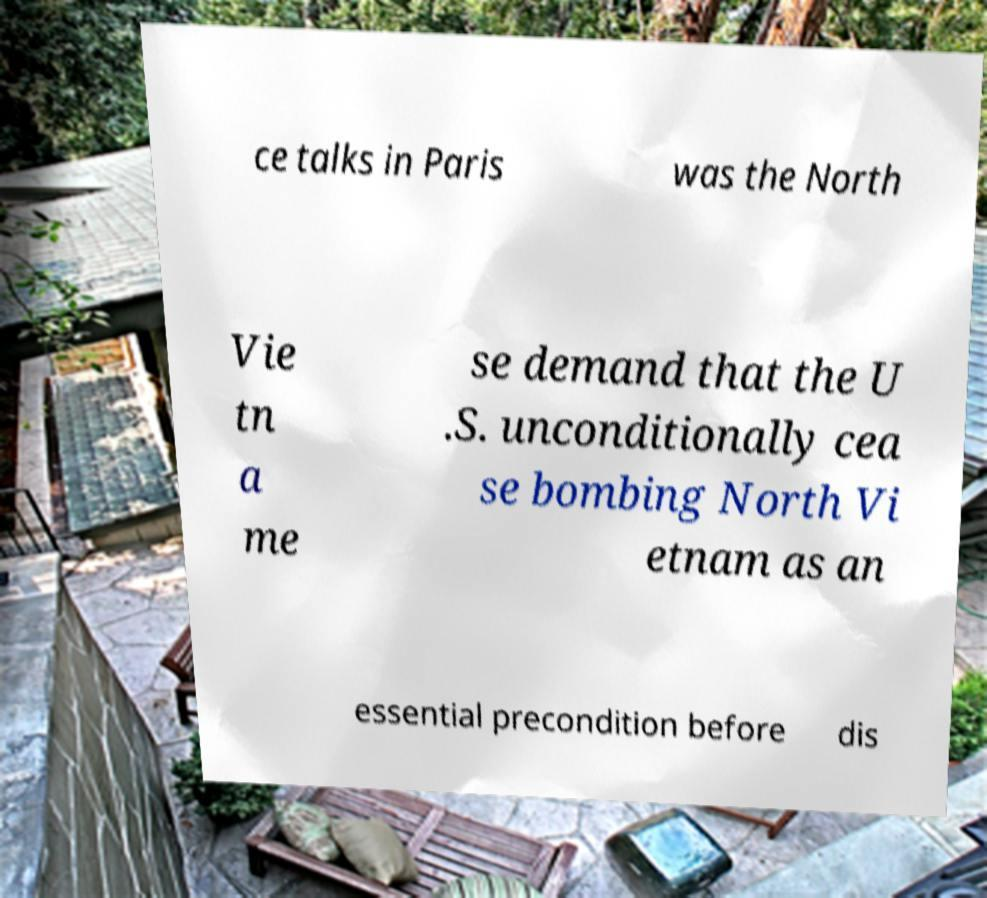I need the written content from this picture converted into text. Can you do that? ce talks in Paris was the North Vie tn a me se demand that the U .S. unconditionally cea se bombing North Vi etnam as an essential precondition before dis 